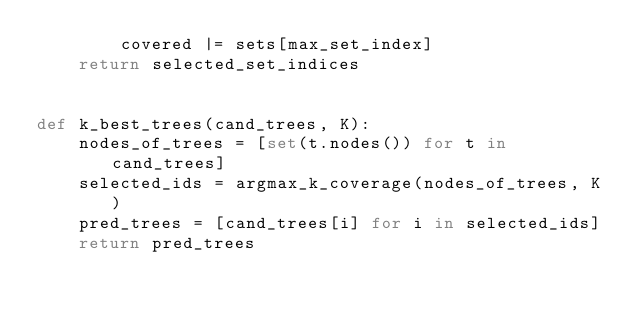Convert code to text. <code><loc_0><loc_0><loc_500><loc_500><_Python_>        covered |= sets[max_set_index]
    return selected_set_indices


def k_best_trees(cand_trees, K):
    nodes_of_trees = [set(t.nodes()) for t in cand_trees]
    selected_ids = argmax_k_coverage(nodes_of_trees, K)
    pred_trees = [cand_trees[i] for i in selected_ids]
    return pred_trees
</code> 